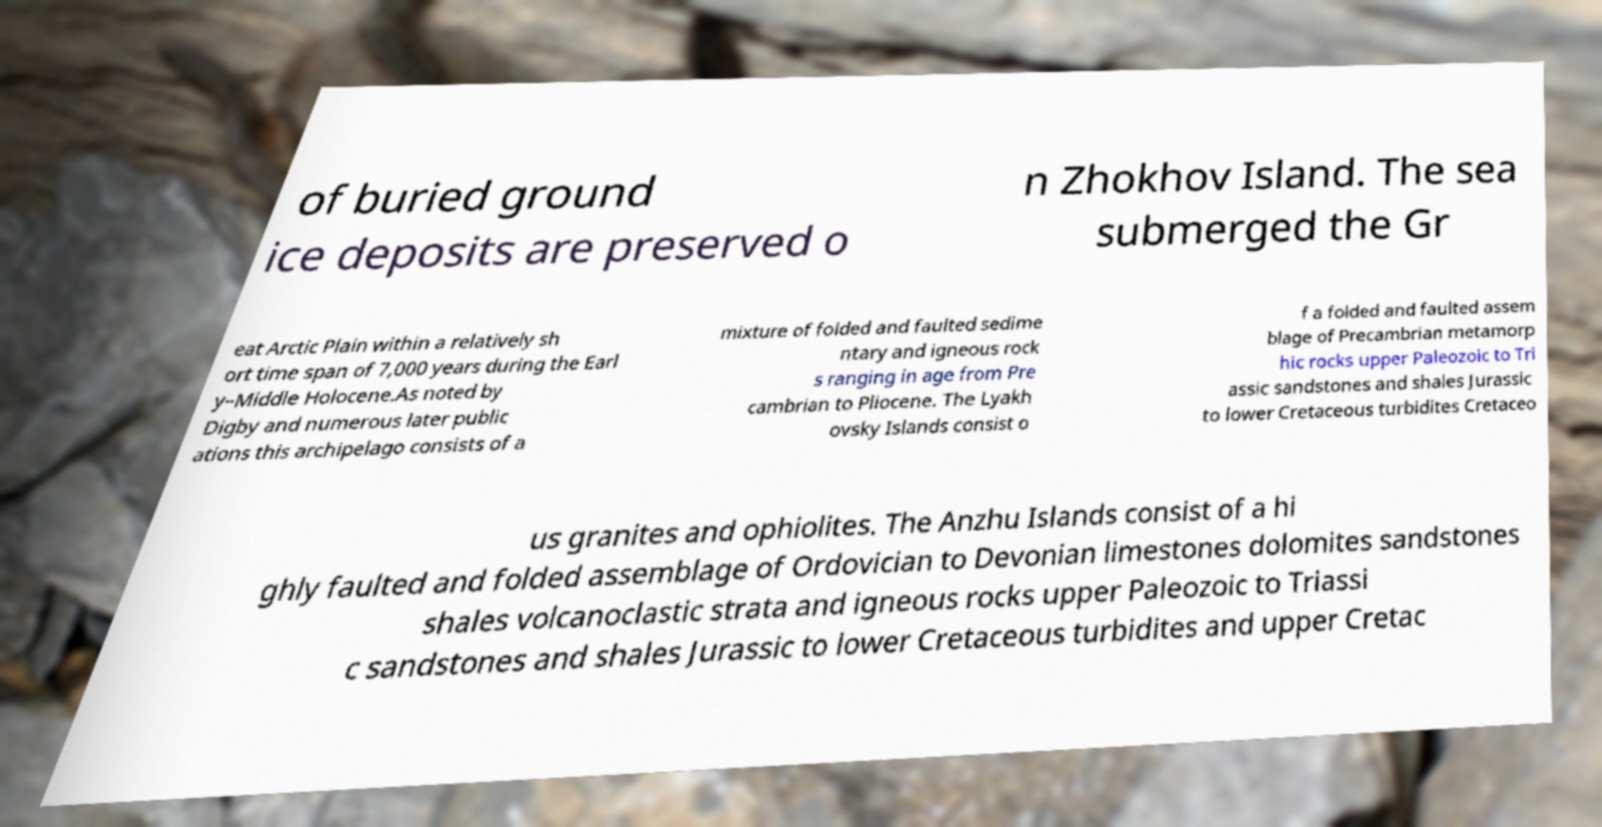Could you assist in decoding the text presented in this image and type it out clearly? of buried ground ice deposits are preserved o n Zhokhov Island. The sea submerged the Gr eat Arctic Plain within a relatively sh ort time span of 7,000 years during the Earl y–Middle Holocene.As noted by Digby and numerous later public ations this archipelago consists of a mixture of folded and faulted sedime ntary and igneous rock s ranging in age from Pre cambrian to Pliocene. The Lyakh ovsky Islands consist o f a folded and faulted assem blage of Precambrian metamorp hic rocks upper Paleozoic to Tri assic sandstones and shales Jurassic to lower Cretaceous turbidites Cretaceo us granites and ophiolites. The Anzhu Islands consist of a hi ghly faulted and folded assemblage of Ordovician to Devonian limestones dolomites sandstones shales volcanoclastic strata and igneous rocks upper Paleozoic to Triassi c sandstones and shales Jurassic to lower Cretaceous turbidites and upper Cretac 